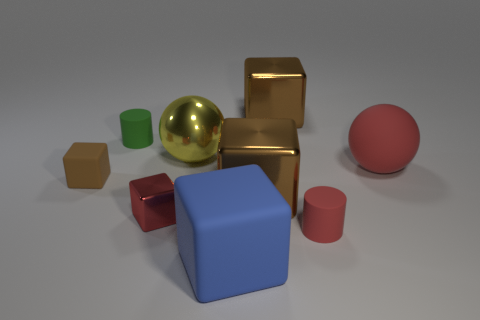What material is the tiny cylinder that is the same color as the rubber sphere?
Ensure brevity in your answer.  Rubber. Is there anything else that is made of the same material as the blue block?
Keep it short and to the point. Yes. Are there any small balls that have the same material as the green cylinder?
Your response must be concise. No. There is a cube that is the same size as the brown rubber thing; what is it made of?
Make the answer very short. Metal. What number of yellow shiny things are the same shape as the red shiny object?
Offer a terse response. 0. The green object that is the same material as the red ball is what size?
Make the answer very short. Small. There is a red thing that is left of the large red rubber ball and behind the small red cylinder; what material is it?
Give a very brief answer. Metal. How many brown blocks are the same size as the red ball?
Offer a terse response. 2. What is the material of the small brown thing that is the same shape as the blue matte object?
Offer a terse response. Rubber. How many things are tiny cubes behind the small shiny thing or blocks that are behind the large red thing?
Offer a very short reply. 2. 